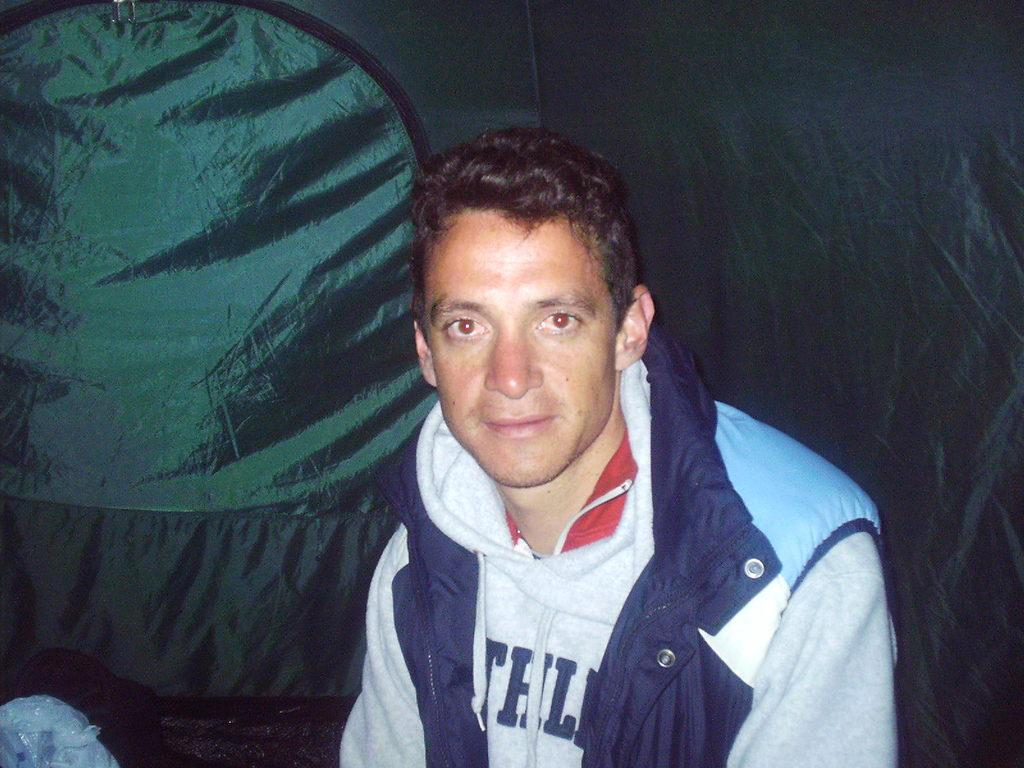Who is the main subject in the image? There is a man in the center of the image. What is the man wearing? The man is wearing a jacket. What can be seen in the background of the image? There is a curtain in the background of the image. What type of pest can be seen in the image? There is no pest present in the image. 